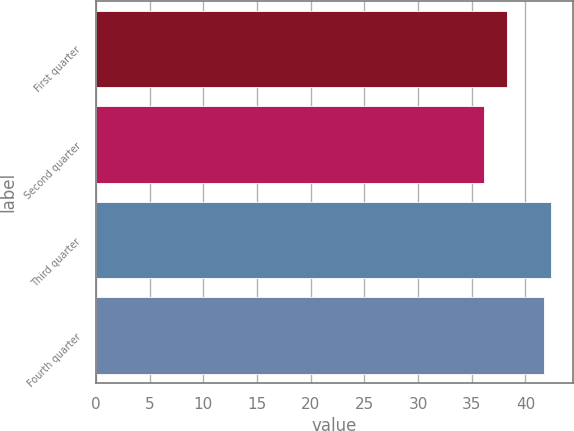Convert chart. <chart><loc_0><loc_0><loc_500><loc_500><bar_chart><fcel>First quarter<fcel>Second quarter<fcel>Third quarter<fcel>Fourth quarter<nl><fcel>38.32<fcel>36.14<fcel>42.34<fcel>41.77<nl></chart> 